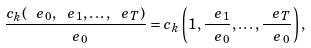<formula> <loc_0><loc_0><loc_500><loc_500>\frac { c _ { k } ( \ e _ { 0 } , \ e _ { 1 } , \dots , \ e _ { T } ) } { \ e _ { 0 } } = c _ { k } \left ( 1 , \frac { \ e _ { 1 } } { \ e _ { 0 } } , \dots , \frac { \ e _ { T } } { \ e _ { 0 } } \right ) ,</formula> 